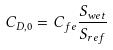Convert formula to latex. <formula><loc_0><loc_0><loc_500><loc_500>C _ { D , 0 } = C _ { f e } \frac { S _ { w e t } } { S _ { r e f } }</formula> 